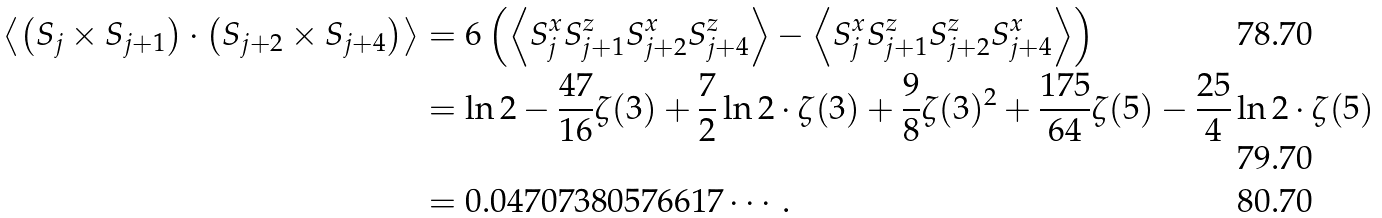<formula> <loc_0><loc_0><loc_500><loc_500>\left \langle \left ( { S } _ { j } \times { S } _ { j + 1 } \right ) \cdot \left ( { S } _ { j + 2 } \times { S } _ { j + 4 } \right ) \right \rangle & = 6 \left ( \left \langle S _ { j } ^ { x } S _ { j + 1 } ^ { z } S _ { j + 2 } ^ { x } S _ { j + 4 } ^ { z } \right \rangle - \left \langle S _ { j } ^ { x } S _ { j + 1 } ^ { z } S _ { j + 2 } ^ { z } S _ { j + 4 } ^ { x } \right \rangle \right ) \\ & = \ln 2 - \frac { 4 7 } { 1 6 } \zeta ( 3 ) + \frac { 7 } { 2 } \ln 2 \cdot \zeta ( 3 ) + \frac { 9 } { 8 } \zeta ( 3 ) ^ { 2 } + \frac { 1 7 5 } { 6 4 } \zeta ( 5 ) - \frac { 2 5 } { 4 } \ln 2 \cdot \zeta ( 5 ) \\ & = 0 . 0 4 7 0 7 3 8 0 5 7 6 6 1 7 \cdots .</formula> 